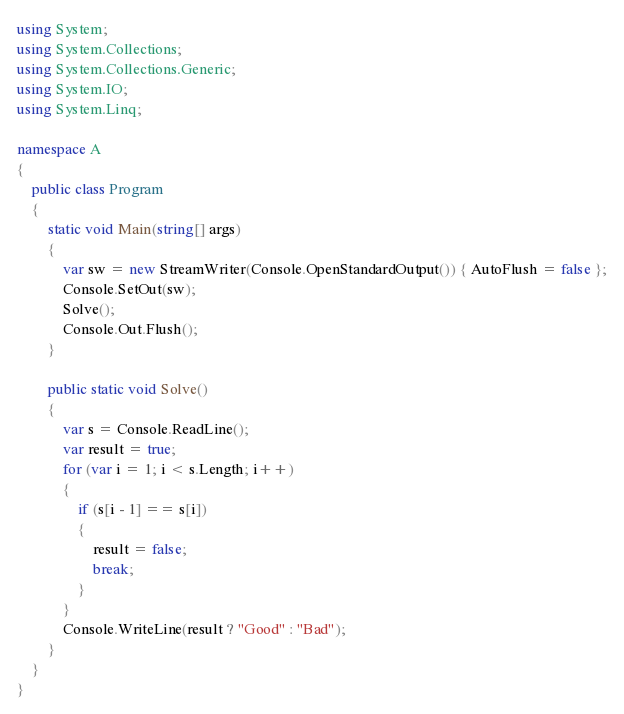Convert code to text. <code><loc_0><loc_0><loc_500><loc_500><_C#_>using System;
using System.Collections;
using System.Collections.Generic;
using System.IO;
using System.Linq;

namespace A
{
    public class Program
    {
        static void Main(string[] args)
        {
            var sw = new StreamWriter(Console.OpenStandardOutput()) { AutoFlush = false };
            Console.SetOut(sw);
            Solve();
            Console.Out.Flush();
        }

        public static void Solve()
        {
            var s = Console.ReadLine();
            var result = true;
            for (var i = 1; i < s.Length; i++)
            {
                if (s[i - 1] == s[i])
                {
                    result = false;
                    break;
                }
            }
            Console.WriteLine(result ? "Good" : "Bad");
        }
    }
}
</code> 